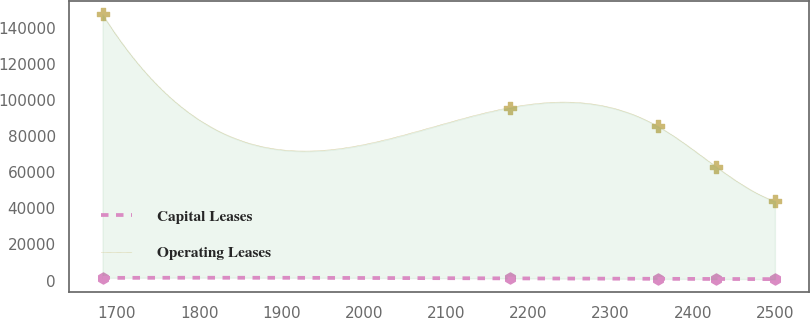Convert chart to OTSL. <chart><loc_0><loc_0><loc_500><loc_500><line_chart><ecel><fcel>Capital Leases<fcel>Operating Leases<nl><fcel>1682.47<fcel>1461.95<fcel>147692<nl><fcel>2177.29<fcel>1162.77<fcel>95947.3<nl><fcel>2357.31<fcel>912.34<fcel>85578.1<nl><fcel>2428.48<fcel>843.37<fcel>63029.1<nl><fcel>2499.65<fcel>772.26<fcel>44000.1<nl></chart> 